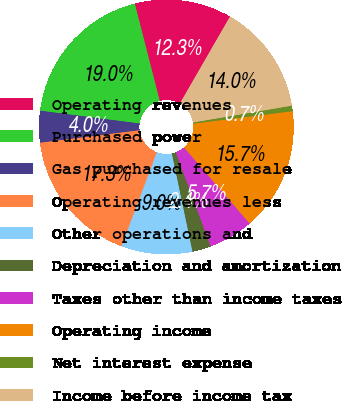Convert chart. <chart><loc_0><loc_0><loc_500><loc_500><pie_chart><fcel>Operating revenues<fcel>Purchased power<fcel>Gas purchased for resale<fcel>Operating revenues less<fcel>Other operations and<fcel>Depreciation and amortization<fcel>Taxes other than income taxes<fcel>Operating income<fcel>Net interest expense<fcel>Income before income tax<nl><fcel>12.32%<fcel>18.97%<fcel>4.02%<fcel>17.31%<fcel>9.0%<fcel>2.36%<fcel>5.68%<fcel>15.65%<fcel>0.7%<fcel>13.99%<nl></chart> 